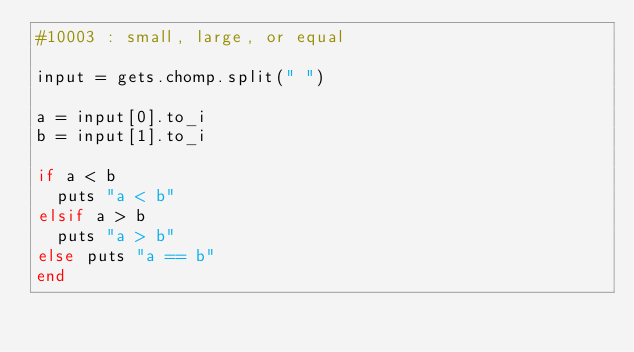Convert code to text. <code><loc_0><loc_0><loc_500><loc_500><_Ruby_>#10003 : small, large, or equal

input = gets.chomp.split(" ")

a = input[0].to_i
b = input[1].to_i

if a < b
  puts "a < b"
elsif a > b
  puts "a > b"
else puts "a == b"
end</code> 